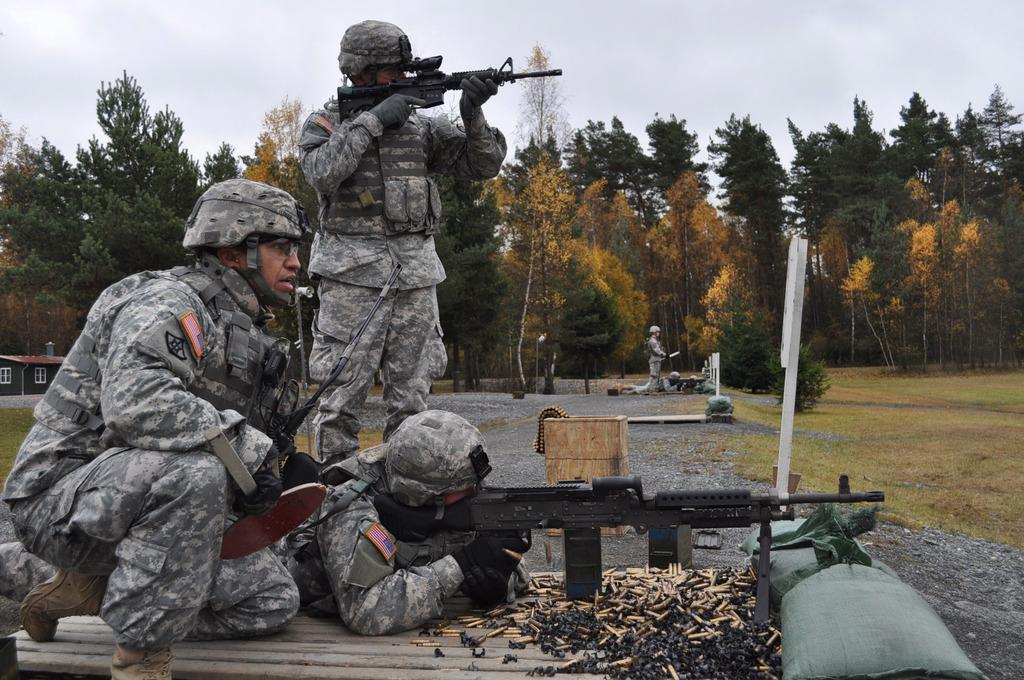In one or two sentences, can you explain what this image depicts? In this image we can see three army man, one is lying on the floor and holding gun. The other one is sitting and the third one is standing and holding gun. They are wearing army uniform. In front of them bullets are there and sack is present. Background we can see so many trees and two more army men. Right side of the image grassy land is present. 